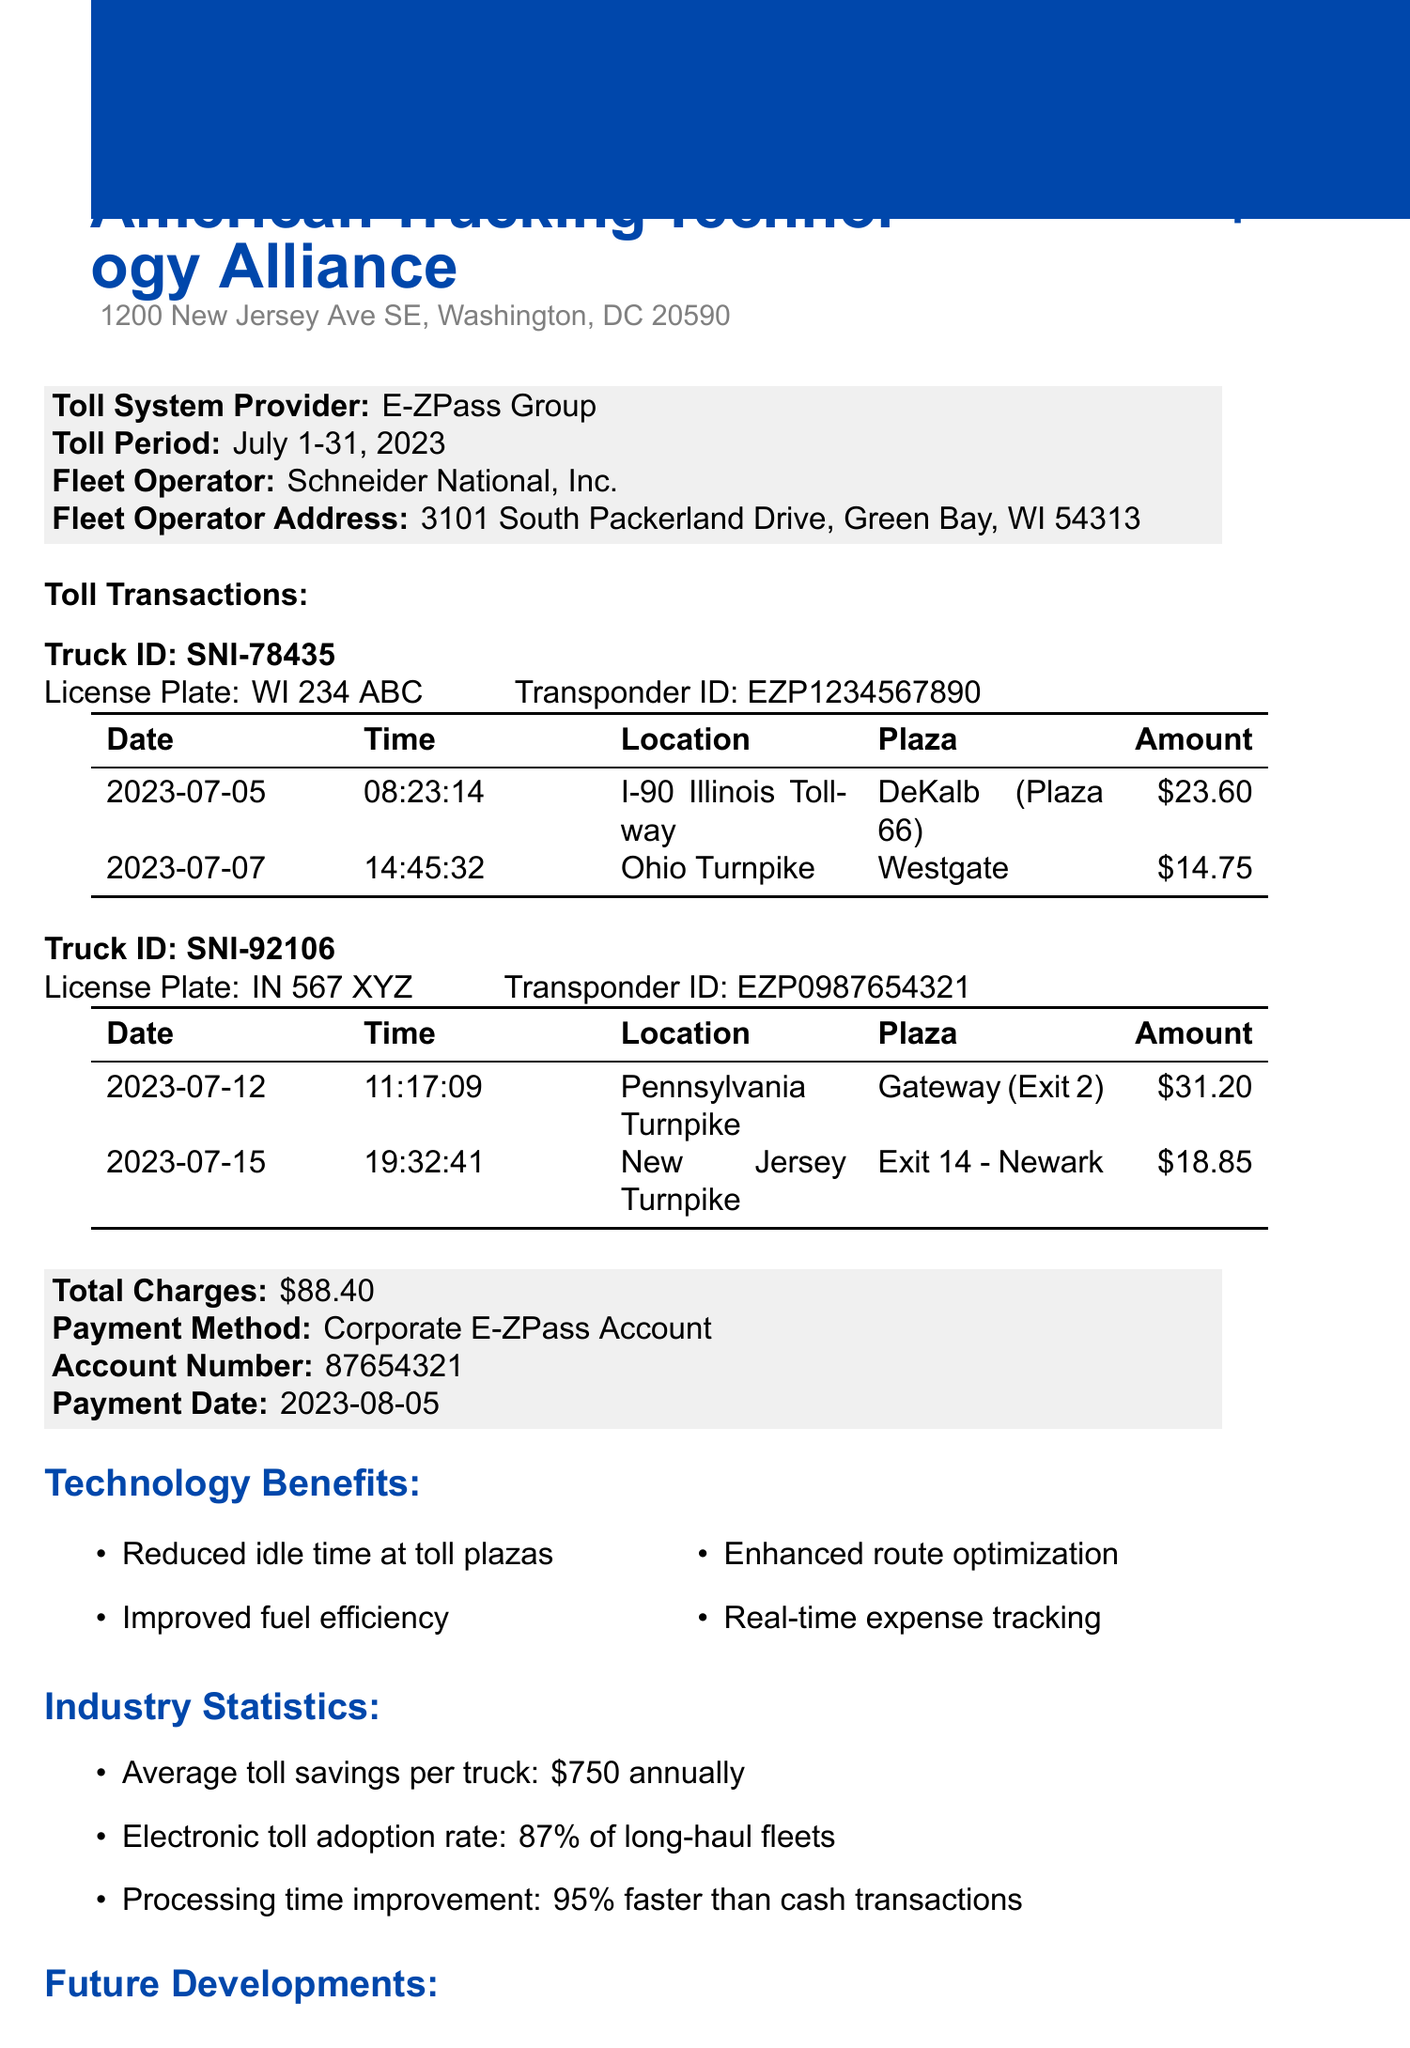What is the association name? The association name is stated at the top of the document.
Answer: American Trucking Technology Alliance What is the total amount of toll charges? The total amount of toll charges is clearly listed in the document.
Answer: 88.40 Who is the fleet operator? The fleet operator's name is provided in a specific section of the document.
Answer: Schneider National, Inc What was the payment date? The payment date is mentioned in the financial summary section of the document.
Answer: 2023-08-05 What is the electronic toll adoption rate? The document provides industry statistics, including this specific rate.
Answer: 87% of long-haul fleets Which toll plaza had a charge of 31.20? The charge of 31.20 is associated with a specific toll transaction location.
Answer: Gateway (Exit 2) What technology benefit reduces idle time at toll plazas? The document lists several technology benefits, including this one.
Answer: Reduced idle time at toll plazas How many toll transactions are listed for truck ID SNI-78435? The number of toll transactions is presented under the specific truck's information.
Answer: 2 What is the contact title of John Smith? The document provides the contact information including the title of John Smith.
Answer: Director of Technology Advocacy 